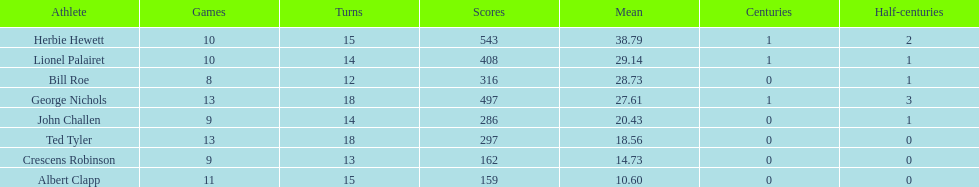What were the number of innings albert clapp had? 15. 